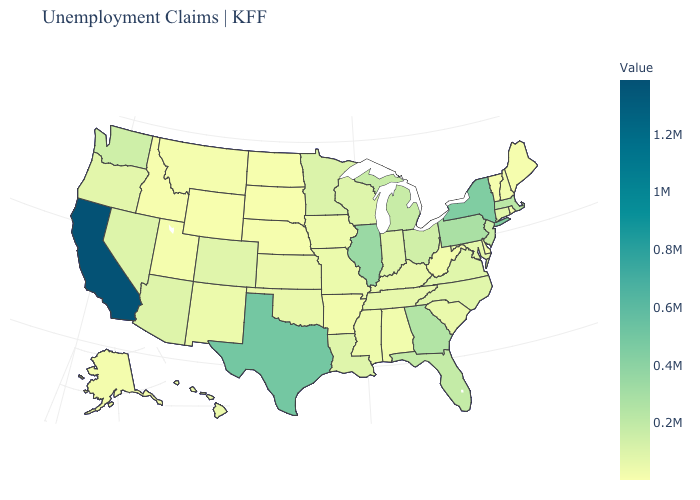Among the states that border Indiana , which have the lowest value?
Short answer required. Kentucky. Is the legend a continuous bar?
Quick response, please. Yes. Is the legend a continuous bar?
Keep it brief. Yes. Does Michigan have a higher value than Delaware?
Give a very brief answer. Yes. 